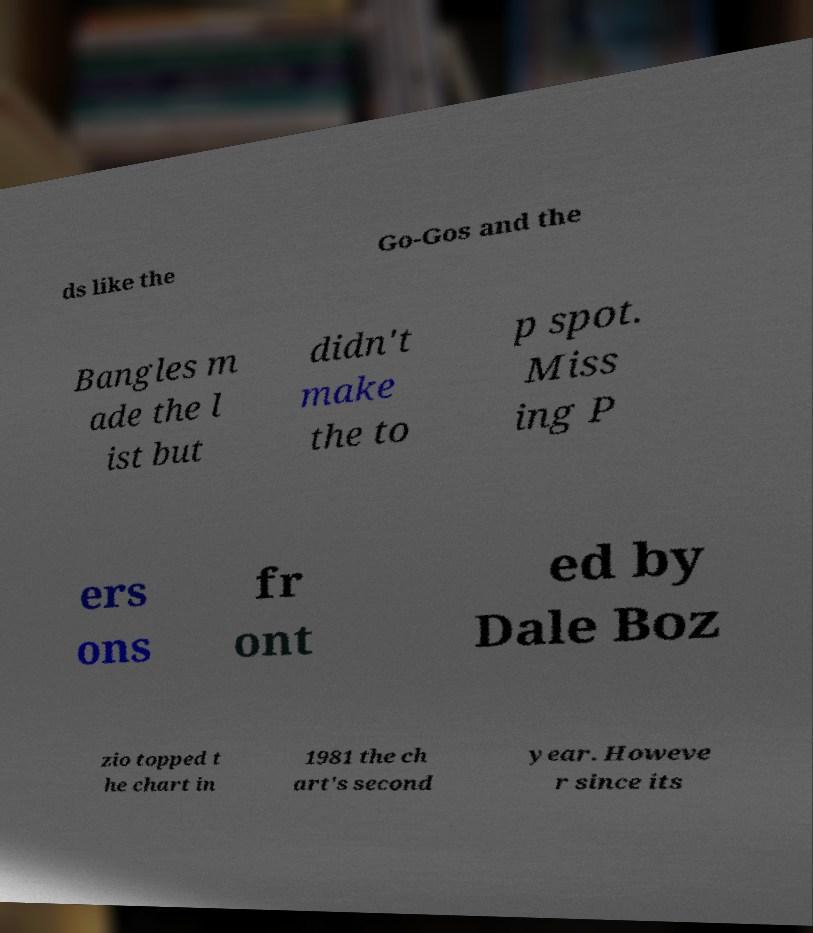Could you assist in decoding the text presented in this image and type it out clearly? ds like the Go-Gos and the Bangles m ade the l ist but didn't make the to p spot. Miss ing P ers ons fr ont ed by Dale Boz zio topped t he chart in 1981 the ch art's second year. Howeve r since its 